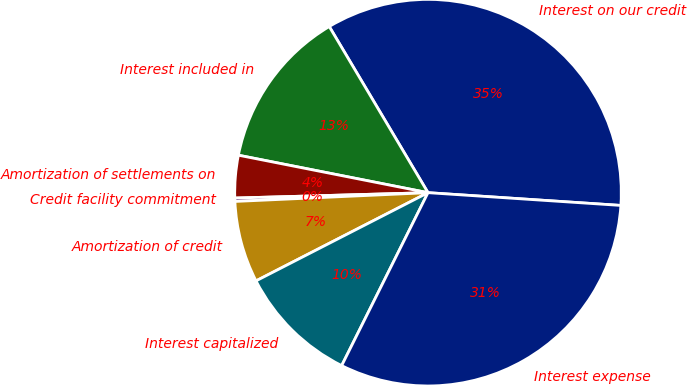Convert chart to OTSL. <chart><loc_0><loc_0><loc_500><loc_500><pie_chart><fcel>Interest on our credit<fcel>Interest included in<fcel>Amortization of settlements on<fcel>Credit facility commitment<fcel>Amortization of credit<fcel>Interest capitalized<fcel>Interest expense<nl><fcel>34.59%<fcel>13.36%<fcel>3.55%<fcel>0.28%<fcel>6.82%<fcel>10.09%<fcel>31.32%<nl></chart> 